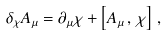<formula> <loc_0><loc_0><loc_500><loc_500>\delta _ { \chi } A _ { \mu } = \partial _ { \mu } \chi + \left [ A _ { \mu } \, , \, \chi \right ] \, ,</formula> 